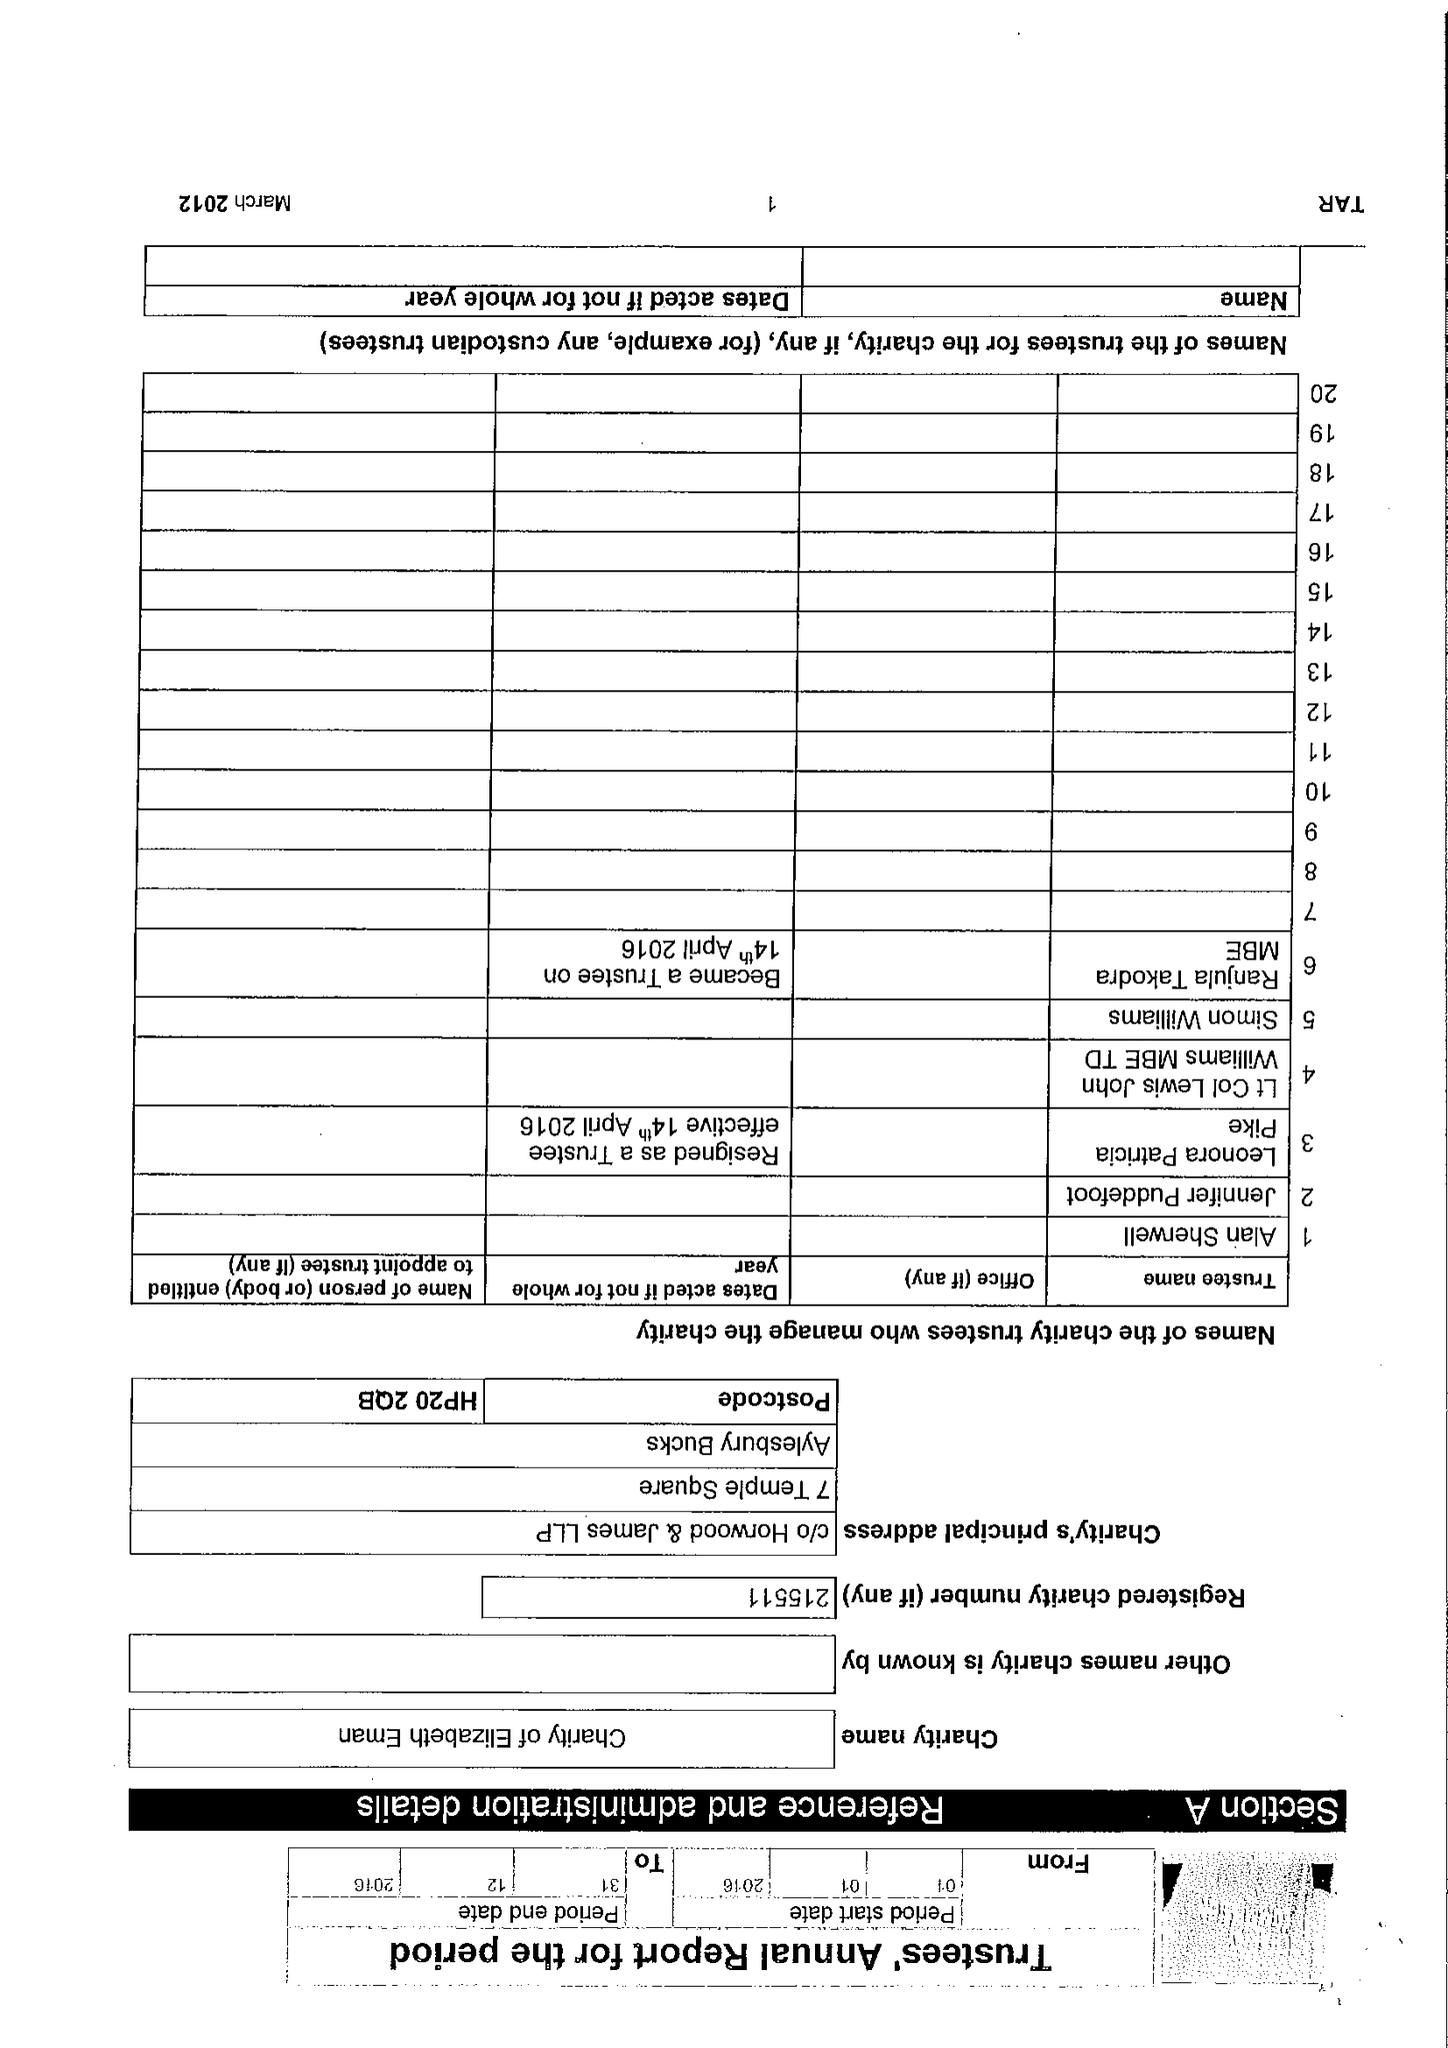What is the value for the report_date?
Answer the question using a single word or phrase. 2016-12-31 